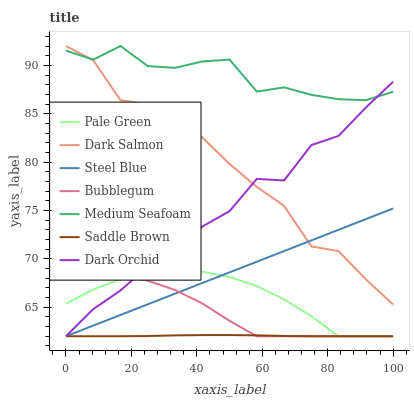Does Saddle Brown have the minimum area under the curve?
Answer yes or no. Yes. Does Medium Seafoam have the maximum area under the curve?
Answer yes or no. Yes. Does Bubblegum have the minimum area under the curve?
Answer yes or no. No. Does Bubblegum have the maximum area under the curve?
Answer yes or no. No. Is Steel Blue the smoothest?
Answer yes or no. Yes. Is Dark Orchid the roughest?
Answer yes or no. Yes. Is Bubblegum the smoothest?
Answer yes or no. No. Is Bubblegum the roughest?
Answer yes or no. No. Does Bubblegum have the lowest value?
Answer yes or no. Yes. Does Medium Seafoam have the lowest value?
Answer yes or no. No. Does Medium Seafoam have the highest value?
Answer yes or no. Yes. Does Bubblegum have the highest value?
Answer yes or no. No. Is Pale Green less than Dark Salmon?
Answer yes or no. Yes. Is Medium Seafoam greater than Bubblegum?
Answer yes or no. Yes. Does Bubblegum intersect Saddle Brown?
Answer yes or no. Yes. Is Bubblegum less than Saddle Brown?
Answer yes or no. No. Is Bubblegum greater than Saddle Brown?
Answer yes or no. No. Does Pale Green intersect Dark Salmon?
Answer yes or no. No. 